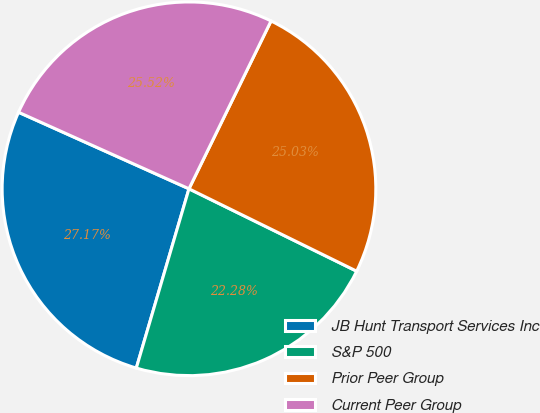Convert chart. <chart><loc_0><loc_0><loc_500><loc_500><pie_chart><fcel>JB Hunt Transport Services Inc<fcel>S&P 500<fcel>Prior Peer Group<fcel>Current Peer Group<nl><fcel>27.17%<fcel>22.28%<fcel>25.03%<fcel>25.52%<nl></chart> 